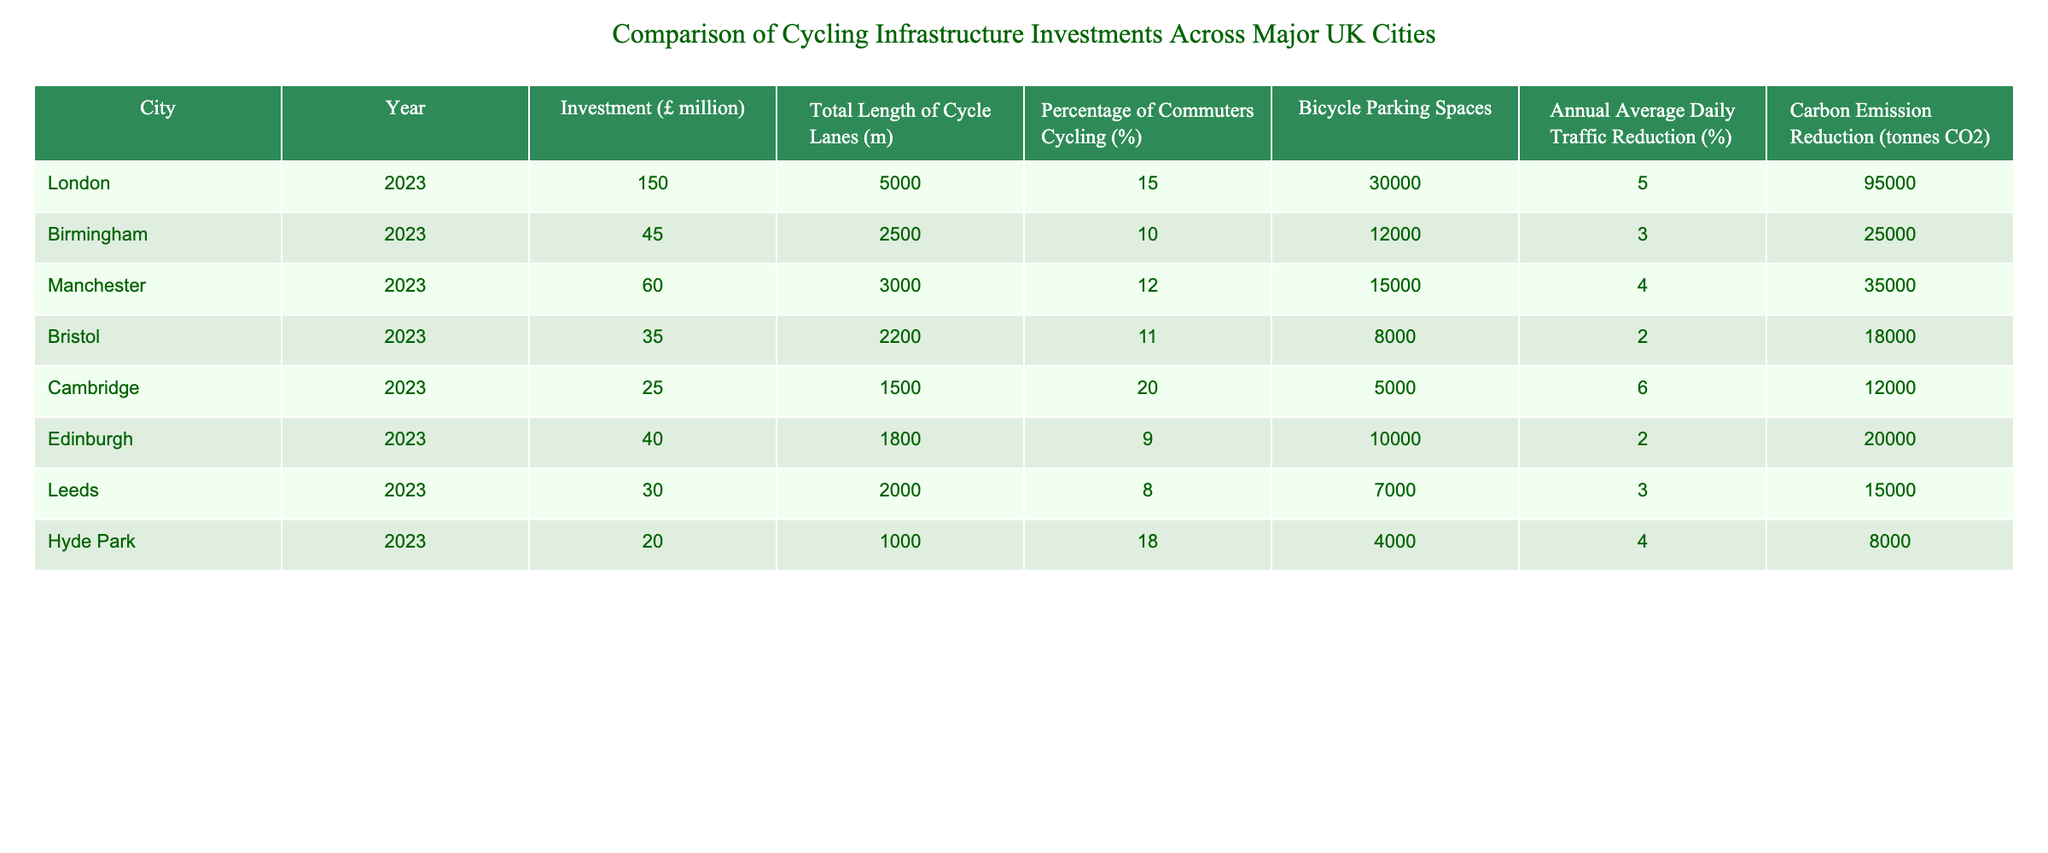What is the total investment in cycling infrastructure across all cities? To find the total investment, add up the investments from all the cities: 150 + 45 + 60 + 35 + 25 + 40 + 30 + 20 = 405 million pounds.
Answer: 405 million pounds Which city has the highest percentage of commuters cycling? Looking at the "Percentage of Commuters Cycling" column, Cambridge has the highest value at 20%.
Answer: Cambridge Is the average length of cycle lanes longer in London compared to Edinburgh? The average length of cycle lanes in London is 5000 m, while in Edinburgh it is 1800 m. Since 5000 m is greater than 1800 m, the statement is true.
Answer: Yes What is the investment per kilometer of cycle lanes for Birmingham? First, convert the length of cycle lanes from meters to kilometers (2500 m = 2.5 km). Then divide the investment (£45 million) by the length in kilometers: 45 / 2.5 = 18 million pounds per kilometer.
Answer: 18 million pounds per kilometer What is the total carbon emission reduction for the cities in the table? Adding up the "Carbon Emission Reduction" values: 95000 + 25000 + 35000 + 18000 + 12000 + 20000 + 15000 + 8000 = 260000 tonnes of CO2.
Answer: 260000 tonnes of CO2 Is the investment in cycling infrastructure proportional to the percentage of commuters cycling in each city? Analyzing the data, cities with higher investment like London (150 million) and Cambridge (25 million) do have higher percentages of cycling commuters but it's not consistent across all cities, indicating no direct proportionality.
Answer: No Which city has the lowest number of bicycle parking spaces? The city with the lowest number of bicycle parking spaces is Hyde Park, with 4000 spaces.
Answer: Hyde Park What is the average annual traffic reduction percentage across all the cities? To find the average, sum the percentages: (5 + 3 + 4 + 2 + 6 + 2 + 3 + 4) = 29, then divide by the number of cities (8): 29 / 8 = 3.625%.
Answer: 3.625% 